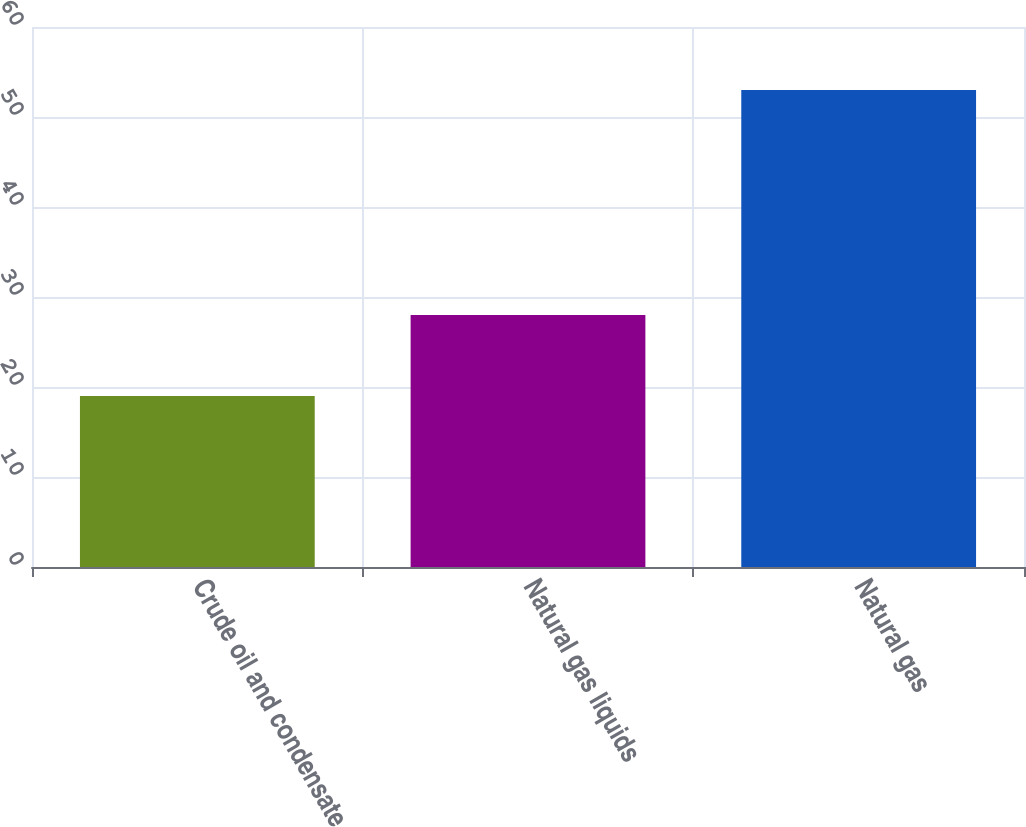Convert chart to OTSL. <chart><loc_0><loc_0><loc_500><loc_500><bar_chart><fcel>Crude oil and condensate<fcel>Natural gas liquids<fcel>Natural gas<nl><fcel>19<fcel>28<fcel>53<nl></chart> 